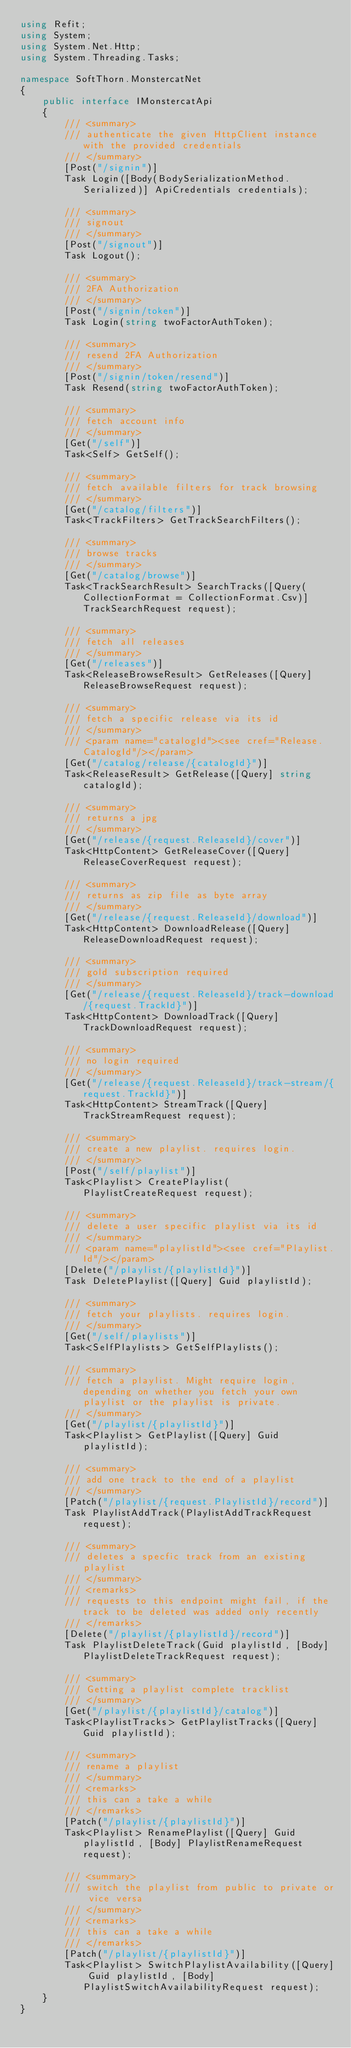Convert code to text. <code><loc_0><loc_0><loc_500><loc_500><_C#_>using Refit;
using System;
using System.Net.Http;
using System.Threading.Tasks;

namespace SoftThorn.MonstercatNet
{
    public interface IMonstercatApi
    {
        /// <summary>
        /// authenticate the given HttpClient instance with the provided credentials
        /// </summary>
        [Post("/signin")]
        Task Login([Body(BodySerializationMethod.Serialized)] ApiCredentials credentials);

        /// <summary>
        /// signout
        /// </summary>
        [Post("/signout")]
        Task Logout();

        /// <summary>
        /// 2FA Authorization
        /// </summary>
        [Post("/signin/token")]
        Task Login(string twoFactorAuthToken);

        /// <summary>
        /// resend 2FA Authorization
        /// </summary>
        [Post("/signin/token/resend")]
        Task Resend(string twoFactorAuthToken);

        /// <summary>
        /// fetch account info
        /// </summary>
        [Get("/self")]
        Task<Self> GetSelf();

        /// <summary>
        /// fetch available filters for track browsing
        /// </summary>
        [Get("/catalog/filters")]
        Task<TrackFilters> GetTrackSearchFilters();

        /// <summary>
        /// browse tracks
        /// </summary>
        [Get("/catalog/browse")]
        Task<TrackSearchResult> SearchTracks([Query(CollectionFormat = CollectionFormat.Csv)] TrackSearchRequest request);

        /// <summary>
        /// fetch all releases
        /// </summary>
        [Get("/releases")]
        Task<ReleaseBrowseResult> GetReleases([Query] ReleaseBrowseRequest request);

        /// <summary>
        /// fetch a specific release via its id
        /// </summary>
        /// <param name="catalogId"><see cref="Release.CatalogId"/></param>
        [Get("/catalog/release/{catalogId}")]
        Task<ReleaseResult> GetRelease([Query] string catalogId);

        /// <summary>
        /// returns a jpg
        /// </summary>
        [Get("/release/{request.ReleaseId}/cover")]
        Task<HttpContent> GetReleaseCover([Query] ReleaseCoverRequest request);

        /// <summary>
        /// returns as zip file as byte array
        /// </summary>
        [Get("/release/{request.ReleaseId}/download")]
        Task<HttpContent> DownloadRelease([Query] ReleaseDownloadRequest request);

        /// <summary>
        /// gold subscription required
        /// </summary>
        [Get("/release/{request.ReleaseId}/track-download/{request.TrackId}")]
        Task<HttpContent> DownloadTrack([Query] TrackDownloadRequest request);

        /// <summary>
        /// no login required
        /// </summary>
        [Get("/release/{request.ReleaseId}/track-stream/{request.TrackId}")]
        Task<HttpContent> StreamTrack([Query] TrackStreamRequest request);

        /// <summary>
        /// create a new playlist. requires login.
        /// </summary>
        [Post("/self/playlist")]
        Task<Playlist> CreatePlaylist(PlaylistCreateRequest request);

        /// <summary>
        /// delete a user specific playlist via its id
        /// </summary>
        /// <param name="playlistId"><see cref="Playlist.Id"/></param>
        [Delete("/playlist/{playlistId}")]
        Task DeletePlaylist([Query] Guid playlistId);

        /// <summary>
        /// fetch your playlists. requires login.
        /// </summary>
        [Get("/self/playlists")]
        Task<SelfPlaylists> GetSelfPlaylists();

        /// <summary>
        /// fetch a playlist. Might require login, depending on whether you fetch your own playlist or the playlist is private.
        /// </summary>
        [Get("/playlist/{playlistId}")]
        Task<Playlist> GetPlaylist([Query] Guid playlistId);

        /// <summary>
        /// add one track to the end of a playlist
        /// </summary>
        [Patch("/playlist/{request.PlaylistId}/record")]
        Task PlaylistAddTrack(PlaylistAddTrackRequest request);

        /// <summary>
        /// deletes a specfic track from an existing playlist
        /// </summary>
        /// <remarks>
        /// requests to this endpoint might fail, if the track to be deleted was added only recently
        /// </remarks>
        [Delete("/playlist/{playlistId}/record")]
        Task PlaylistDeleteTrack(Guid playlistId, [Body] PlaylistDeleteTrackRequest request);

        /// <summary>
        /// Getting a playlist complete tracklist
        /// </summary>
        [Get("/playlist/{playlistId}/catalog")]
        Task<PlaylistTracks> GetPlaylistTracks([Query] Guid playlistId);

        /// <summary>
        /// rename a playlist
        /// </summary>
        /// <remarks>
        /// this can a take a while
        /// </remarks>
        [Patch("/playlist/{playlistId}")]
        Task<Playlist> RenamePlaylist([Query] Guid playlistId, [Body] PlaylistRenameRequest request);

        /// <summary>
        /// switch the playlist from public to private or vice versa
        /// </summary>
        /// <remarks>
        /// this can a take a while
        /// </remarks>
        [Patch("/playlist/{playlistId}")]
        Task<Playlist> SwitchPlaylistAvailability([Query] Guid playlistId, [Body] PlaylistSwitchAvailabilityRequest request);
    }
}
</code> 